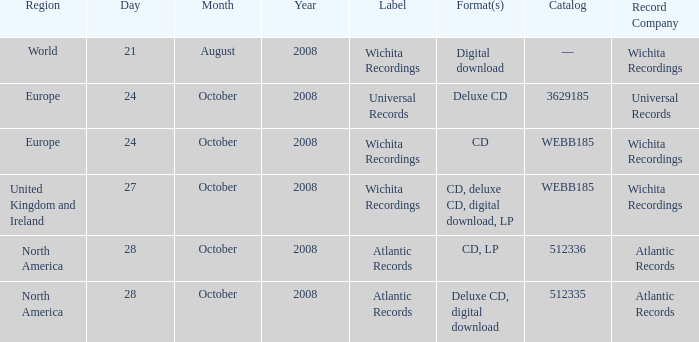Which catalog value has a region of world? —. 